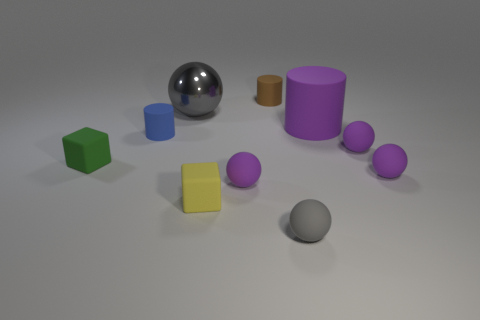There is a object that is behind the blue cylinder and in front of the big gray shiny ball; what is its shape?
Your answer should be compact. Cylinder. Is there anything else that is the same size as the gray matte ball?
Your answer should be very brief. Yes. There is a gray thing that is made of the same material as the yellow block; what size is it?
Keep it short and to the point. Small. How many objects are purple things that are behind the tiny blue rubber object or gray things that are left of the brown thing?
Offer a very short reply. 2. Does the purple rubber thing behind the blue matte cylinder have the same size as the blue thing?
Offer a terse response. No. What color is the small cylinder that is behind the big rubber thing?
Your answer should be very brief. Brown. There is another small thing that is the same shape as the small brown matte object; what is its color?
Make the answer very short. Blue. How many small rubber cubes are in front of the tiny yellow thing that is to the left of the rubber cylinder that is behind the large gray sphere?
Your response must be concise. 0. Is there any other thing that is made of the same material as the large ball?
Keep it short and to the point. No. Is the number of small blue cylinders right of the brown cylinder less than the number of purple matte cylinders?
Ensure brevity in your answer.  Yes. 